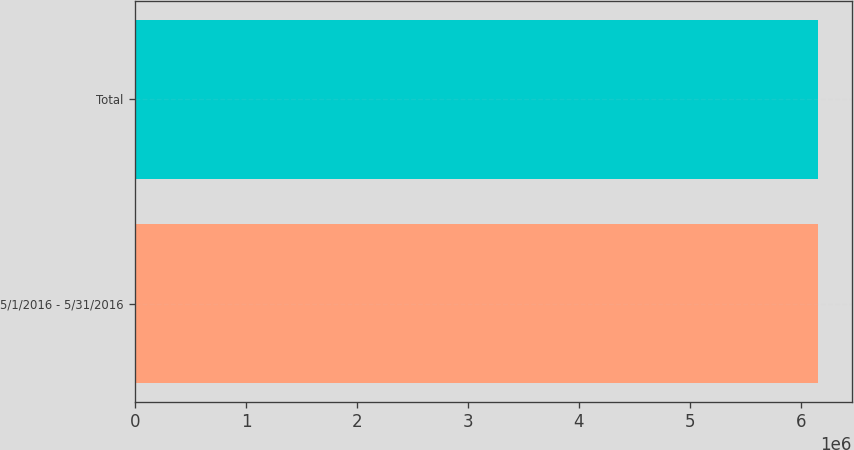<chart> <loc_0><loc_0><loc_500><loc_500><bar_chart><fcel>5/1/2016 - 5/31/2016<fcel>Total<nl><fcel>6.15215e+06<fcel>6.15215e+06<nl></chart> 